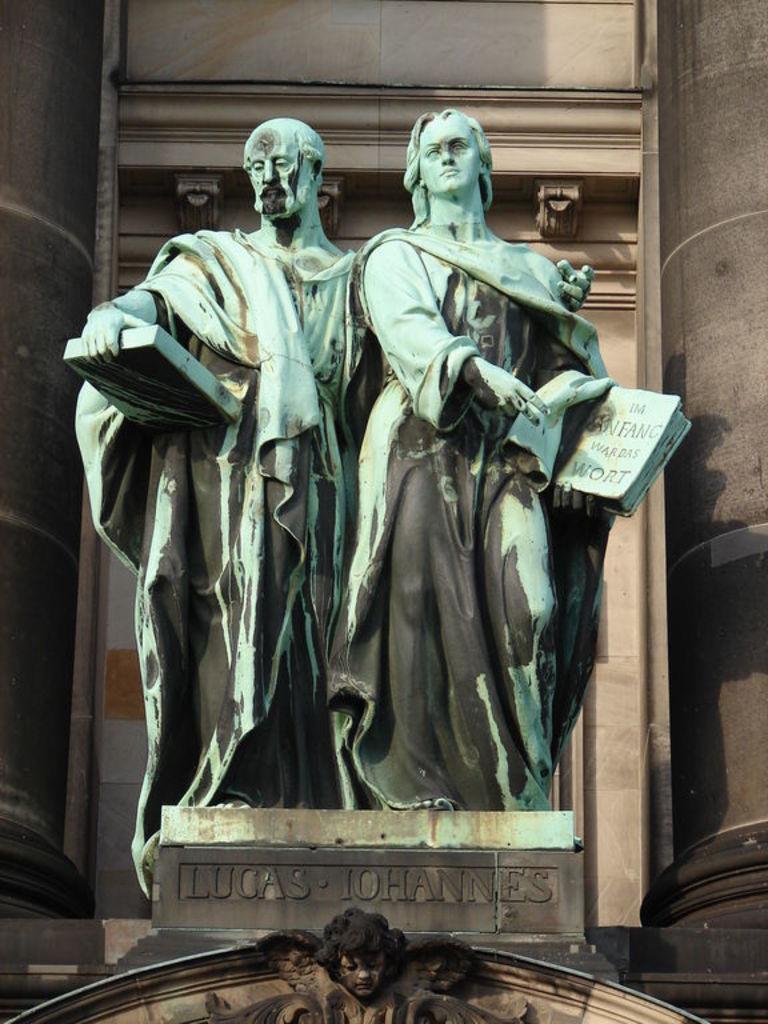Please provide a concise description of this image. In the picture we can see two persons sculptures on the stone and behind it we can see a wall which is cream in color and on the stone we can see a name LUCAS JOHNNIE 